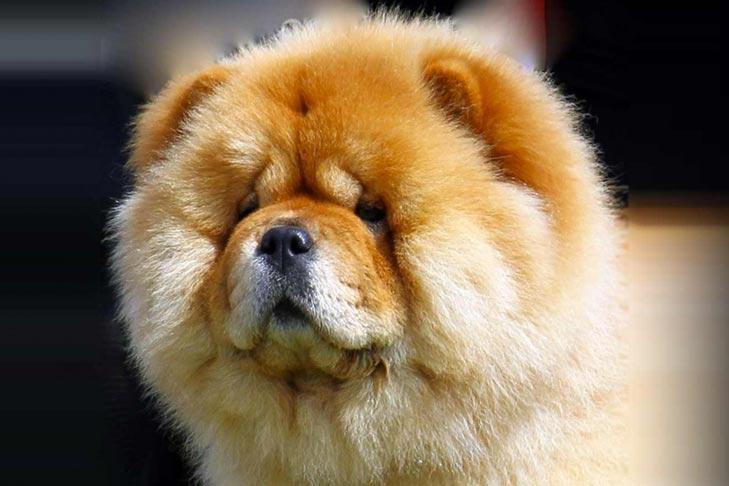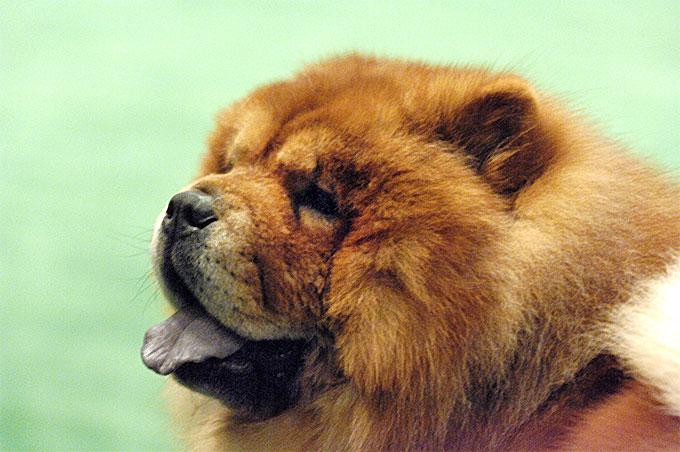The first image is the image on the left, the second image is the image on the right. For the images displayed, is the sentence "In at least one image, there’s a single dark brown dog with a purple tongue sticking out as his light brown tail sits on his back, while he stands." factually correct? Answer yes or no. No. The first image is the image on the left, the second image is the image on the right. For the images shown, is this caption "in at least one image there ia a dog fully visable on the grass" true? Answer yes or no. No. 